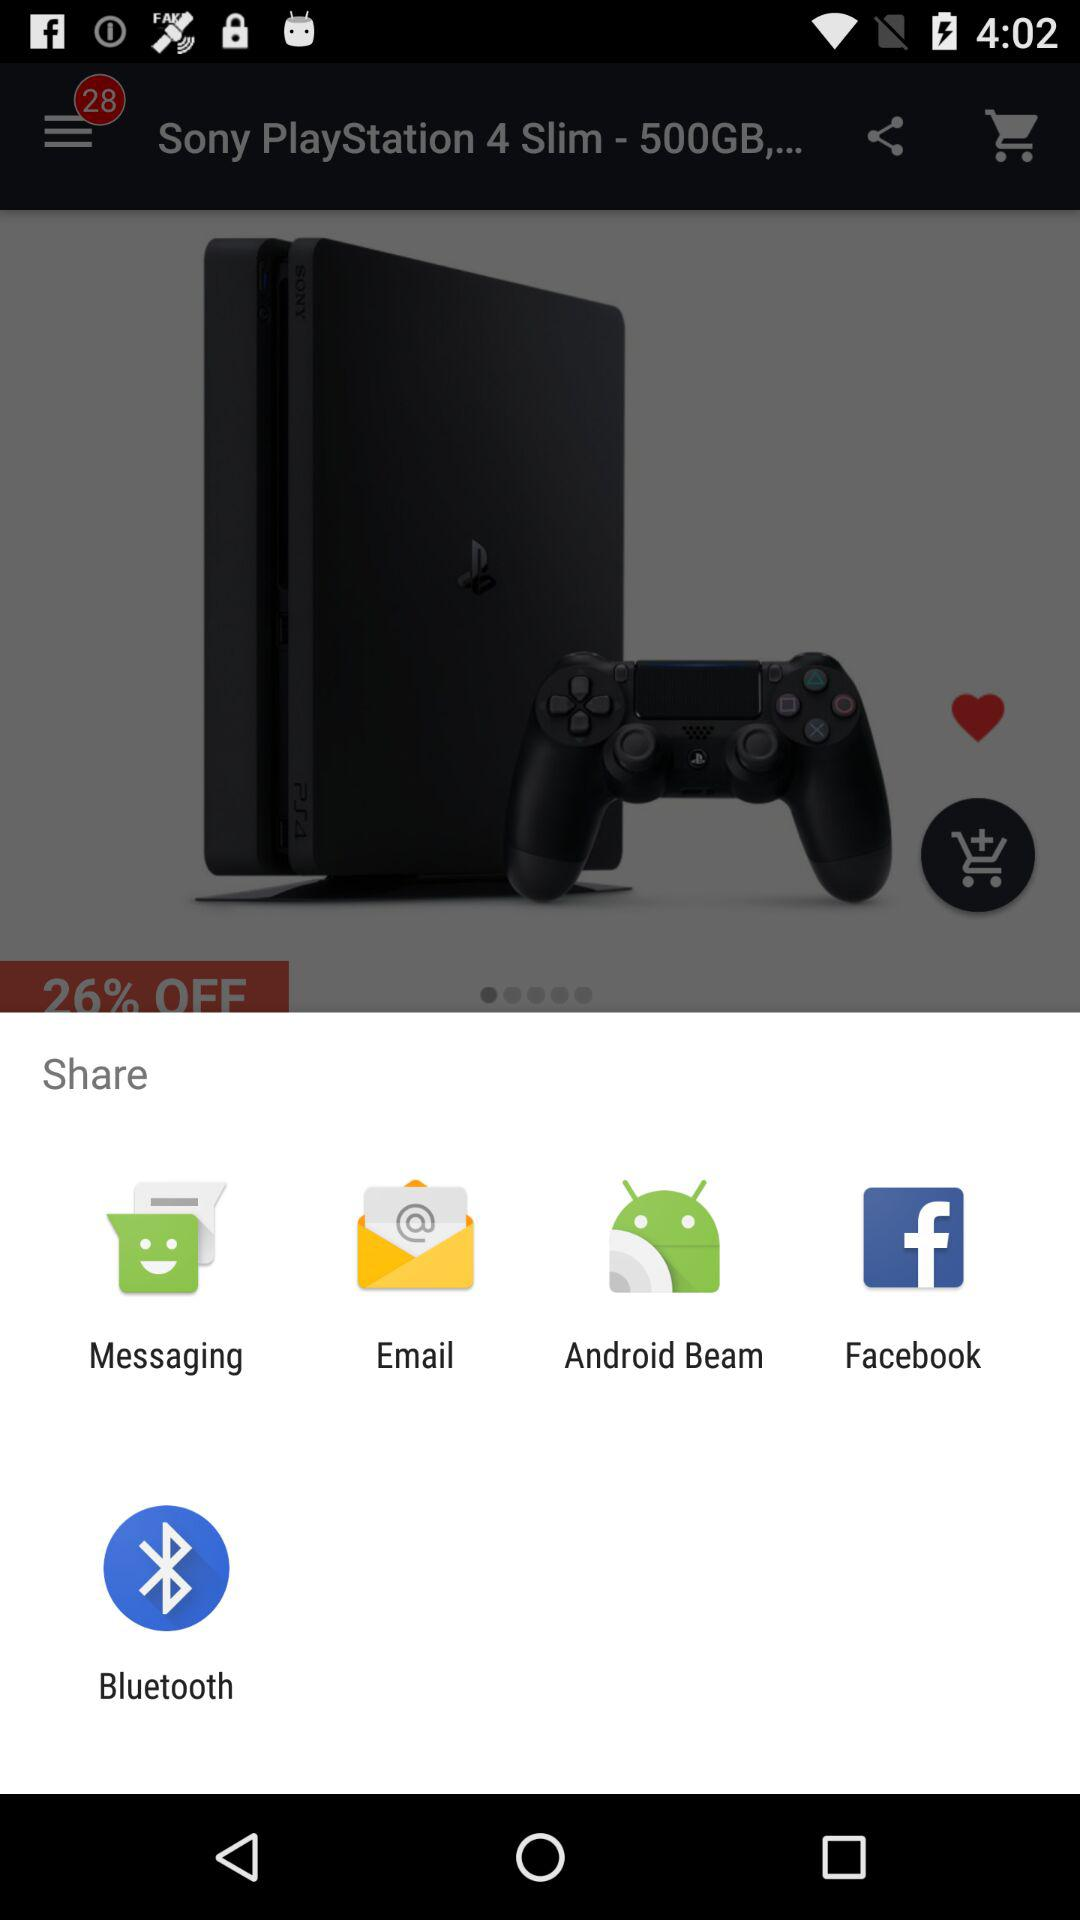How many items are in the navbar?
Answer the question using a single word or phrase. 3 